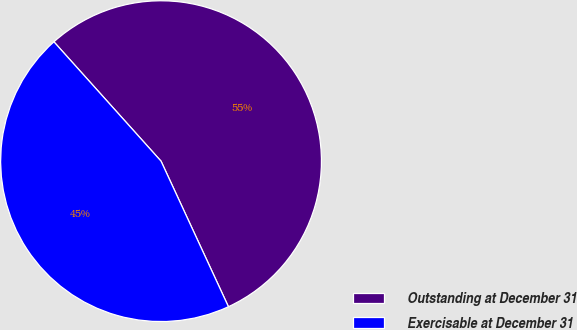Convert chart. <chart><loc_0><loc_0><loc_500><loc_500><pie_chart><fcel>Outstanding at December 31<fcel>Exercisable at December 31<nl><fcel>54.74%<fcel>45.26%<nl></chart> 